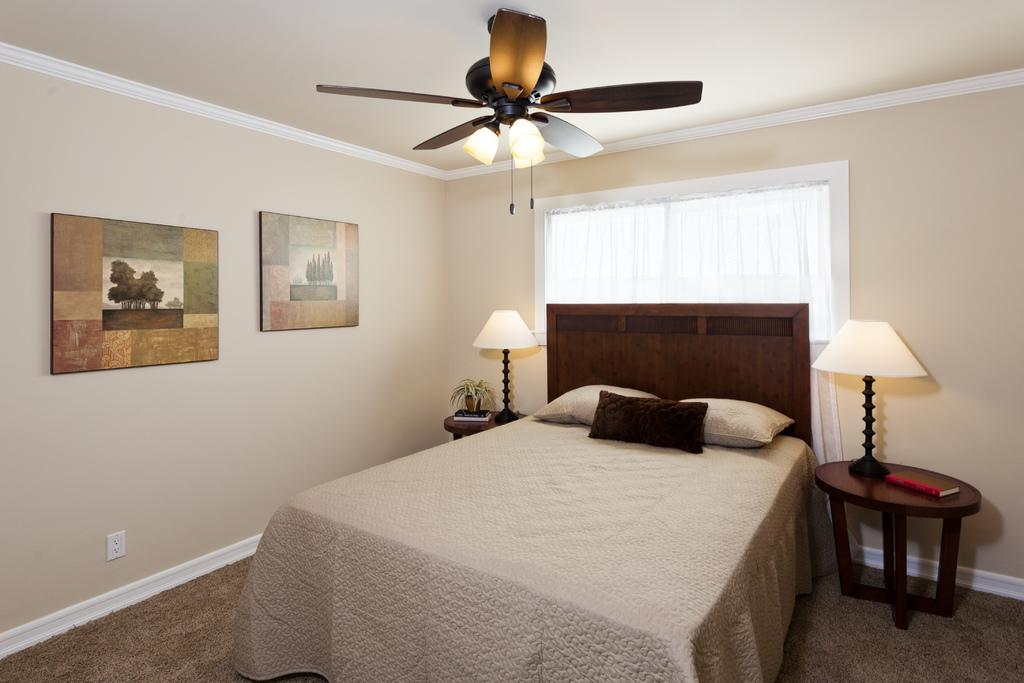What type of room might the image be taken in? The image might be taken in a bedroom. What furniture is present in the bedroom? There is a bed in the image. What is covering the bed? There is a bed sheet on the bed. What is used for head support on the bed? There are pillows on the bed. What type of lighting is present in the image? There are lights in the image. What can be seen on the bed? There is at least one book in the image. What other furniture is present in the room? There is a table in the image. What type of decorations are present in the room? There are photo frames in the image. What is visible outside the room? There is a window in the image. What type of appliance is present in the room? There is a fan in the image. What type of structure is present in the room? There is a wall in the image. How many planes can be seen flying outside the window in the image? There are no planes visible in the image; it only shows a window and the view outside. 